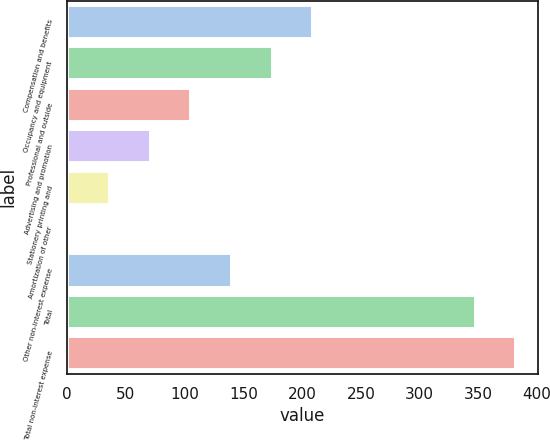Convert chart to OTSL. <chart><loc_0><loc_0><loc_500><loc_500><bar_chart><fcel>Compensation and benefits<fcel>Occupancy and equipment<fcel>Professional and outside<fcel>Advertising and promotion<fcel>Stationery printing and<fcel>Amortization of other<fcel>Other non-interest expense<fcel>Total<fcel>Total non-interest expense<nl><fcel>208.58<fcel>174<fcel>104.84<fcel>70.26<fcel>35.68<fcel>1.1<fcel>139.42<fcel>346.9<fcel>381.48<nl></chart> 